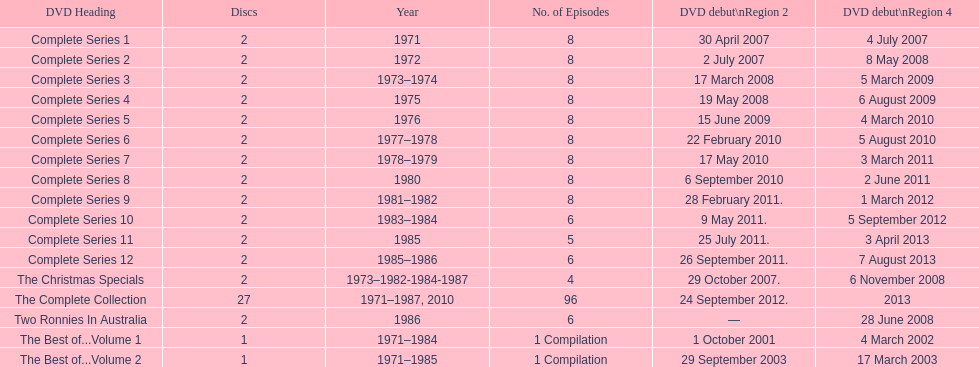Total number of episodes released in region 2 in 2007 20. 